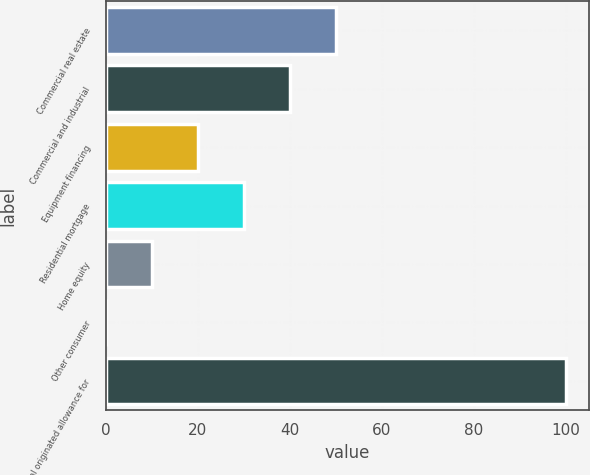<chart> <loc_0><loc_0><loc_500><loc_500><bar_chart><fcel>Commercial real estate<fcel>Commercial and industrial<fcel>Equipment financing<fcel>Residential mortgage<fcel>Home equity<fcel>Other consumer<fcel>Total originated allowance for<nl><fcel>50.05<fcel>40.06<fcel>20.08<fcel>30.07<fcel>10.09<fcel>0.1<fcel>100<nl></chart> 